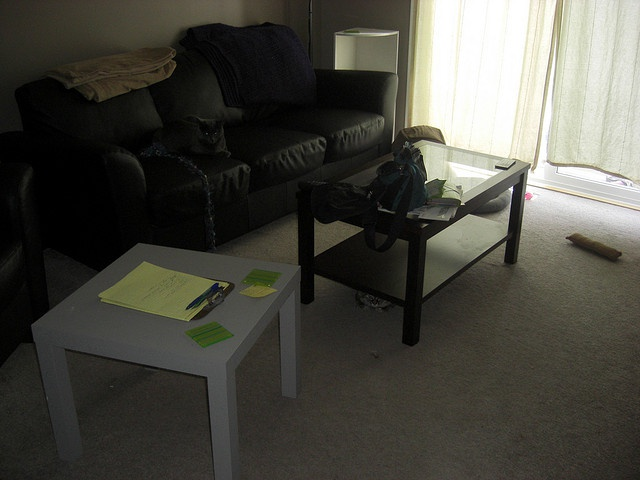Describe the objects in this image and their specific colors. I can see couch in black and gray tones, dining table in black, gray, and darkgreen tones, dining table in black, gray, darkgray, and ivory tones, chair in black tones, and handbag in black and gray tones in this image. 